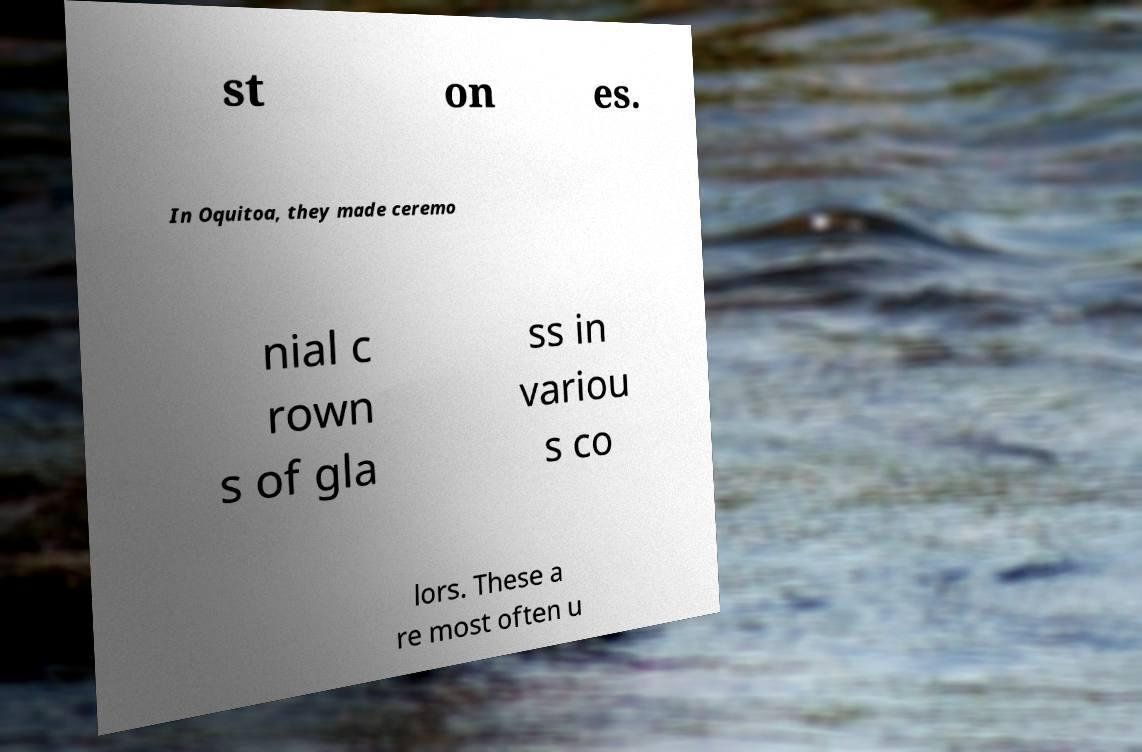Can you read and provide the text displayed in the image?This photo seems to have some interesting text. Can you extract and type it out for me? st on es. In Oquitoa, they made ceremo nial c rown s of gla ss in variou s co lors. These a re most often u 